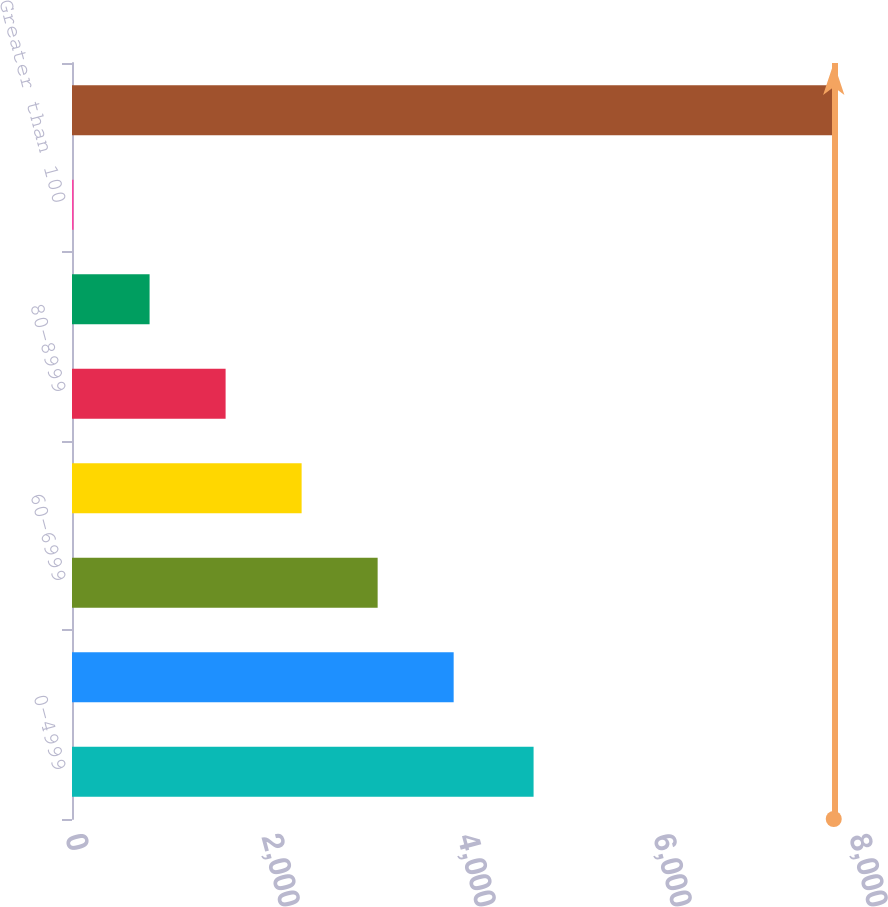Convert chart. <chart><loc_0><loc_0><loc_500><loc_500><bar_chart><fcel>0-4999<fcel>50-5999<fcel>60-6999<fcel>70-7999<fcel>80-8999<fcel>90-100<fcel>Greater than 100<fcel>Total Commercial Mortgage and<nl><fcel>4710<fcel>3894.5<fcel>3118.8<fcel>2343.1<fcel>1567.4<fcel>791.7<fcel>16<fcel>7773<nl></chart> 